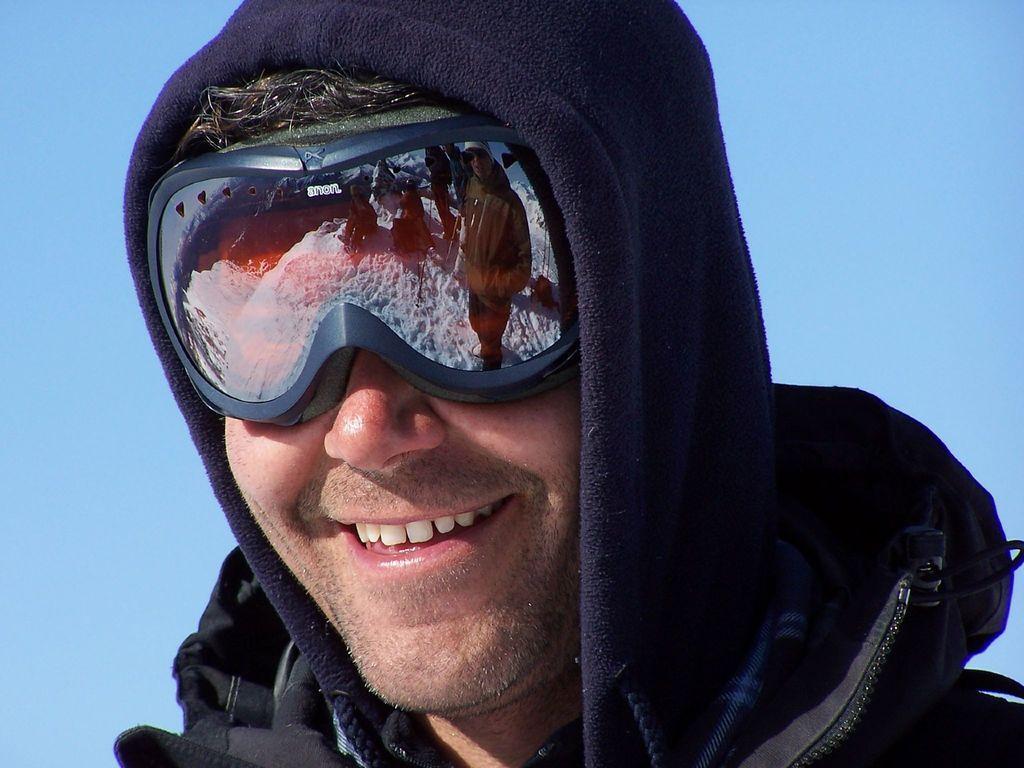Can you describe this image briefly? In this image we can see a man is standing, and smiling, he is wearing the black dress, at above the sky is in blue color. 